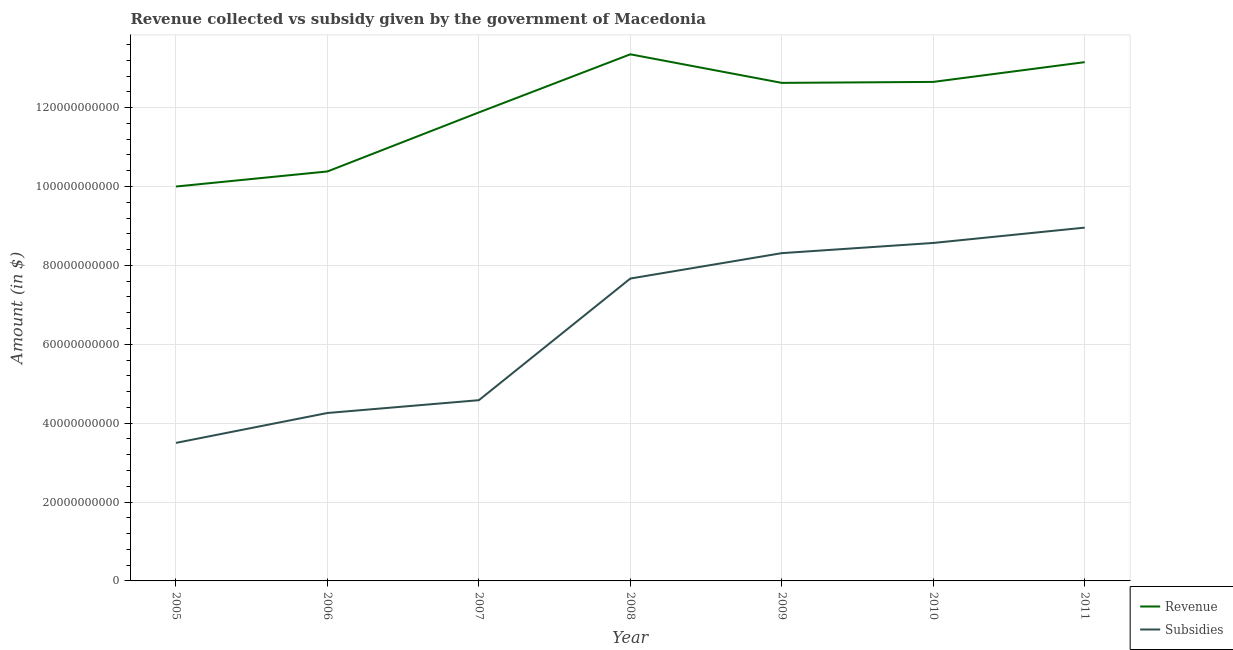How many different coloured lines are there?
Make the answer very short. 2. Is the number of lines equal to the number of legend labels?
Provide a short and direct response. Yes. What is the amount of revenue collected in 2008?
Your answer should be very brief. 1.34e+11. Across all years, what is the maximum amount of revenue collected?
Offer a terse response. 1.34e+11. Across all years, what is the minimum amount of revenue collected?
Your response must be concise. 1.00e+11. What is the total amount of revenue collected in the graph?
Provide a succinct answer. 8.40e+11. What is the difference between the amount of subsidies given in 2005 and that in 2009?
Keep it short and to the point. -4.81e+1. What is the difference between the amount of subsidies given in 2006 and the amount of revenue collected in 2007?
Offer a terse response. -7.62e+1. What is the average amount of subsidies given per year?
Your answer should be compact. 6.55e+1. In the year 2010, what is the difference between the amount of revenue collected and amount of subsidies given?
Your answer should be very brief. 4.08e+1. What is the ratio of the amount of revenue collected in 2006 to that in 2011?
Provide a succinct answer. 0.79. Is the amount of subsidies given in 2007 less than that in 2011?
Make the answer very short. Yes. What is the difference between the highest and the second highest amount of revenue collected?
Provide a succinct answer. 1.99e+09. What is the difference between the highest and the lowest amount of subsidies given?
Provide a succinct answer. 5.46e+1. Does the amount of subsidies given monotonically increase over the years?
Ensure brevity in your answer.  Yes. Are the values on the major ticks of Y-axis written in scientific E-notation?
Your answer should be compact. No. Where does the legend appear in the graph?
Provide a succinct answer. Bottom right. How are the legend labels stacked?
Provide a short and direct response. Vertical. What is the title of the graph?
Provide a succinct answer. Revenue collected vs subsidy given by the government of Macedonia. Does "Under five" appear as one of the legend labels in the graph?
Provide a short and direct response. No. What is the label or title of the X-axis?
Offer a very short reply. Year. What is the label or title of the Y-axis?
Offer a very short reply. Amount (in $). What is the Amount (in $) in Revenue in 2005?
Provide a short and direct response. 1.00e+11. What is the Amount (in $) in Subsidies in 2005?
Offer a terse response. 3.50e+1. What is the Amount (in $) of Revenue in 2006?
Give a very brief answer. 1.04e+11. What is the Amount (in $) in Subsidies in 2006?
Provide a short and direct response. 4.26e+1. What is the Amount (in $) of Revenue in 2007?
Your answer should be very brief. 1.19e+11. What is the Amount (in $) in Subsidies in 2007?
Your response must be concise. 4.58e+1. What is the Amount (in $) of Revenue in 2008?
Offer a very short reply. 1.34e+11. What is the Amount (in $) in Subsidies in 2008?
Provide a short and direct response. 7.67e+1. What is the Amount (in $) of Revenue in 2009?
Your answer should be very brief. 1.26e+11. What is the Amount (in $) in Subsidies in 2009?
Offer a terse response. 8.31e+1. What is the Amount (in $) in Revenue in 2010?
Your answer should be compact. 1.27e+11. What is the Amount (in $) in Subsidies in 2010?
Make the answer very short. 8.57e+1. What is the Amount (in $) of Revenue in 2011?
Offer a terse response. 1.32e+11. What is the Amount (in $) in Subsidies in 2011?
Provide a short and direct response. 8.96e+1. Across all years, what is the maximum Amount (in $) of Revenue?
Your response must be concise. 1.34e+11. Across all years, what is the maximum Amount (in $) of Subsidies?
Make the answer very short. 8.96e+1. Across all years, what is the minimum Amount (in $) of Revenue?
Provide a succinct answer. 1.00e+11. Across all years, what is the minimum Amount (in $) of Subsidies?
Offer a very short reply. 3.50e+1. What is the total Amount (in $) of Revenue in the graph?
Your response must be concise. 8.40e+11. What is the total Amount (in $) in Subsidies in the graph?
Provide a succinct answer. 4.58e+11. What is the difference between the Amount (in $) of Revenue in 2005 and that in 2006?
Offer a very short reply. -3.82e+09. What is the difference between the Amount (in $) of Subsidies in 2005 and that in 2006?
Make the answer very short. -7.58e+09. What is the difference between the Amount (in $) in Revenue in 2005 and that in 2007?
Offer a terse response. -1.88e+1. What is the difference between the Amount (in $) of Subsidies in 2005 and that in 2007?
Your response must be concise. -1.08e+1. What is the difference between the Amount (in $) of Revenue in 2005 and that in 2008?
Make the answer very short. -3.35e+1. What is the difference between the Amount (in $) of Subsidies in 2005 and that in 2008?
Your response must be concise. -4.17e+1. What is the difference between the Amount (in $) in Revenue in 2005 and that in 2009?
Offer a terse response. -2.63e+1. What is the difference between the Amount (in $) in Subsidies in 2005 and that in 2009?
Ensure brevity in your answer.  -4.81e+1. What is the difference between the Amount (in $) in Revenue in 2005 and that in 2010?
Provide a succinct answer. -2.65e+1. What is the difference between the Amount (in $) of Subsidies in 2005 and that in 2010?
Make the answer very short. -5.07e+1. What is the difference between the Amount (in $) in Revenue in 2005 and that in 2011?
Give a very brief answer. -3.15e+1. What is the difference between the Amount (in $) of Subsidies in 2005 and that in 2011?
Make the answer very short. -5.46e+1. What is the difference between the Amount (in $) in Revenue in 2006 and that in 2007?
Provide a short and direct response. -1.50e+1. What is the difference between the Amount (in $) of Subsidies in 2006 and that in 2007?
Ensure brevity in your answer.  -3.25e+09. What is the difference between the Amount (in $) in Revenue in 2006 and that in 2008?
Provide a succinct answer. -2.97e+1. What is the difference between the Amount (in $) of Subsidies in 2006 and that in 2008?
Your answer should be very brief. -3.41e+1. What is the difference between the Amount (in $) of Revenue in 2006 and that in 2009?
Your answer should be compact. -2.25e+1. What is the difference between the Amount (in $) in Subsidies in 2006 and that in 2009?
Give a very brief answer. -4.05e+1. What is the difference between the Amount (in $) of Revenue in 2006 and that in 2010?
Make the answer very short. -2.27e+1. What is the difference between the Amount (in $) of Subsidies in 2006 and that in 2010?
Offer a terse response. -4.31e+1. What is the difference between the Amount (in $) in Revenue in 2006 and that in 2011?
Your answer should be very brief. -2.77e+1. What is the difference between the Amount (in $) in Subsidies in 2006 and that in 2011?
Give a very brief answer. -4.70e+1. What is the difference between the Amount (in $) in Revenue in 2007 and that in 2008?
Ensure brevity in your answer.  -1.47e+1. What is the difference between the Amount (in $) in Subsidies in 2007 and that in 2008?
Make the answer very short. -3.08e+1. What is the difference between the Amount (in $) of Revenue in 2007 and that in 2009?
Keep it short and to the point. -7.49e+09. What is the difference between the Amount (in $) of Subsidies in 2007 and that in 2009?
Your answer should be compact. -3.73e+1. What is the difference between the Amount (in $) of Revenue in 2007 and that in 2010?
Your answer should be compact. -7.73e+09. What is the difference between the Amount (in $) in Subsidies in 2007 and that in 2010?
Your answer should be very brief. -3.99e+1. What is the difference between the Amount (in $) in Revenue in 2007 and that in 2011?
Provide a succinct answer. -1.27e+1. What is the difference between the Amount (in $) of Subsidies in 2007 and that in 2011?
Give a very brief answer. -4.37e+1. What is the difference between the Amount (in $) of Revenue in 2008 and that in 2009?
Provide a succinct answer. 7.24e+09. What is the difference between the Amount (in $) of Subsidies in 2008 and that in 2009?
Keep it short and to the point. -6.44e+09. What is the difference between the Amount (in $) of Revenue in 2008 and that in 2010?
Your response must be concise. 7.00e+09. What is the difference between the Amount (in $) of Subsidies in 2008 and that in 2010?
Offer a very short reply. -9.02e+09. What is the difference between the Amount (in $) of Revenue in 2008 and that in 2011?
Offer a very short reply. 1.99e+09. What is the difference between the Amount (in $) in Subsidies in 2008 and that in 2011?
Give a very brief answer. -1.29e+1. What is the difference between the Amount (in $) of Revenue in 2009 and that in 2010?
Ensure brevity in your answer.  -2.45e+08. What is the difference between the Amount (in $) of Subsidies in 2009 and that in 2010?
Your answer should be compact. -2.58e+09. What is the difference between the Amount (in $) of Revenue in 2009 and that in 2011?
Keep it short and to the point. -5.25e+09. What is the difference between the Amount (in $) of Subsidies in 2009 and that in 2011?
Your answer should be very brief. -6.47e+09. What is the difference between the Amount (in $) of Revenue in 2010 and that in 2011?
Keep it short and to the point. -5.01e+09. What is the difference between the Amount (in $) in Subsidies in 2010 and that in 2011?
Ensure brevity in your answer.  -3.89e+09. What is the difference between the Amount (in $) in Revenue in 2005 and the Amount (in $) in Subsidies in 2006?
Your answer should be compact. 5.74e+1. What is the difference between the Amount (in $) in Revenue in 2005 and the Amount (in $) in Subsidies in 2007?
Offer a very short reply. 5.42e+1. What is the difference between the Amount (in $) of Revenue in 2005 and the Amount (in $) of Subsidies in 2008?
Your answer should be very brief. 2.33e+1. What is the difference between the Amount (in $) of Revenue in 2005 and the Amount (in $) of Subsidies in 2009?
Provide a succinct answer. 1.69e+1. What is the difference between the Amount (in $) of Revenue in 2005 and the Amount (in $) of Subsidies in 2010?
Your answer should be compact. 1.43e+1. What is the difference between the Amount (in $) in Revenue in 2005 and the Amount (in $) in Subsidies in 2011?
Ensure brevity in your answer.  1.04e+1. What is the difference between the Amount (in $) in Revenue in 2006 and the Amount (in $) in Subsidies in 2007?
Ensure brevity in your answer.  5.80e+1. What is the difference between the Amount (in $) in Revenue in 2006 and the Amount (in $) in Subsidies in 2008?
Ensure brevity in your answer.  2.71e+1. What is the difference between the Amount (in $) in Revenue in 2006 and the Amount (in $) in Subsidies in 2009?
Ensure brevity in your answer.  2.07e+1. What is the difference between the Amount (in $) in Revenue in 2006 and the Amount (in $) in Subsidies in 2010?
Your answer should be compact. 1.81e+1. What is the difference between the Amount (in $) in Revenue in 2006 and the Amount (in $) in Subsidies in 2011?
Provide a short and direct response. 1.42e+1. What is the difference between the Amount (in $) in Revenue in 2007 and the Amount (in $) in Subsidies in 2008?
Provide a short and direct response. 4.21e+1. What is the difference between the Amount (in $) in Revenue in 2007 and the Amount (in $) in Subsidies in 2009?
Make the answer very short. 3.57e+1. What is the difference between the Amount (in $) of Revenue in 2007 and the Amount (in $) of Subsidies in 2010?
Provide a short and direct response. 3.31e+1. What is the difference between the Amount (in $) in Revenue in 2007 and the Amount (in $) in Subsidies in 2011?
Provide a succinct answer. 2.92e+1. What is the difference between the Amount (in $) in Revenue in 2008 and the Amount (in $) in Subsidies in 2009?
Give a very brief answer. 5.04e+1. What is the difference between the Amount (in $) in Revenue in 2008 and the Amount (in $) in Subsidies in 2010?
Provide a succinct answer. 4.78e+1. What is the difference between the Amount (in $) of Revenue in 2008 and the Amount (in $) of Subsidies in 2011?
Your answer should be compact. 4.39e+1. What is the difference between the Amount (in $) of Revenue in 2009 and the Amount (in $) of Subsidies in 2010?
Your answer should be compact. 4.06e+1. What is the difference between the Amount (in $) of Revenue in 2009 and the Amount (in $) of Subsidies in 2011?
Provide a succinct answer. 3.67e+1. What is the difference between the Amount (in $) in Revenue in 2010 and the Amount (in $) in Subsidies in 2011?
Your response must be concise. 3.69e+1. What is the average Amount (in $) in Revenue per year?
Offer a terse response. 1.20e+11. What is the average Amount (in $) of Subsidies per year?
Give a very brief answer. 6.55e+1. In the year 2005, what is the difference between the Amount (in $) in Revenue and Amount (in $) in Subsidies?
Provide a succinct answer. 6.50e+1. In the year 2006, what is the difference between the Amount (in $) in Revenue and Amount (in $) in Subsidies?
Give a very brief answer. 6.12e+1. In the year 2007, what is the difference between the Amount (in $) in Revenue and Amount (in $) in Subsidies?
Give a very brief answer. 7.30e+1. In the year 2008, what is the difference between the Amount (in $) of Revenue and Amount (in $) of Subsidies?
Keep it short and to the point. 5.68e+1. In the year 2009, what is the difference between the Amount (in $) of Revenue and Amount (in $) of Subsidies?
Give a very brief answer. 4.32e+1. In the year 2010, what is the difference between the Amount (in $) in Revenue and Amount (in $) in Subsidies?
Give a very brief answer. 4.08e+1. In the year 2011, what is the difference between the Amount (in $) of Revenue and Amount (in $) of Subsidies?
Provide a succinct answer. 4.19e+1. What is the ratio of the Amount (in $) of Revenue in 2005 to that in 2006?
Offer a terse response. 0.96. What is the ratio of the Amount (in $) of Subsidies in 2005 to that in 2006?
Make the answer very short. 0.82. What is the ratio of the Amount (in $) of Revenue in 2005 to that in 2007?
Provide a succinct answer. 0.84. What is the ratio of the Amount (in $) in Subsidies in 2005 to that in 2007?
Keep it short and to the point. 0.76. What is the ratio of the Amount (in $) of Revenue in 2005 to that in 2008?
Keep it short and to the point. 0.75. What is the ratio of the Amount (in $) in Subsidies in 2005 to that in 2008?
Your answer should be compact. 0.46. What is the ratio of the Amount (in $) of Revenue in 2005 to that in 2009?
Ensure brevity in your answer.  0.79. What is the ratio of the Amount (in $) in Subsidies in 2005 to that in 2009?
Your response must be concise. 0.42. What is the ratio of the Amount (in $) in Revenue in 2005 to that in 2010?
Ensure brevity in your answer.  0.79. What is the ratio of the Amount (in $) of Subsidies in 2005 to that in 2010?
Provide a short and direct response. 0.41. What is the ratio of the Amount (in $) in Revenue in 2005 to that in 2011?
Your answer should be compact. 0.76. What is the ratio of the Amount (in $) in Subsidies in 2005 to that in 2011?
Keep it short and to the point. 0.39. What is the ratio of the Amount (in $) of Revenue in 2006 to that in 2007?
Your answer should be compact. 0.87. What is the ratio of the Amount (in $) in Subsidies in 2006 to that in 2007?
Keep it short and to the point. 0.93. What is the ratio of the Amount (in $) in Revenue in 2006 to that in 2008?
Keep it short and to the point. 0.78. What is the ratio of the Amount (in $) of Subsidies in 2006 to that in 2008?
Your answer should be compact. 0.56. What is the ratio of the Amount (in $) of Revenue in 2006 to that in 2009?
Your answer should be compact. 0.82. What is the ratio of the Amount (in $) of Subsidies in 2006 to that in 2009?
Your response must be concise. 0.51. What is the ratio of the Amount (in $) of Revenue in 2006 to that in 2010?
Make the answer very short. 0.82. What is the ratio of the Amount (in $) of Subsidies in 2006 to that in 2010?
Give a very brief answer. 0.5. What is the ratio of the Amount (in $) in Revenue in 2006 to that in 2011?
Offer a very short reply. 0.79. What is the ratio of the Amount (in $) in Subsidies in 2006 to that in 2011?
Your response must be concise. 0.48. What is the ratio of the Amount (in $) in Revenue in 2007 to that in 2008?
Your response must be concise. 0.89. What is the ratio of the Amount (in $) of Subsidies in 2007 to that in 2008?
Make the answer very short. 0.6. What is the ratio of the Amount (in $) of Revenue in 2007 to that in 2009?
Offer a very short reply. 0.94. What is the ratio of the Amount (in $) in Subsidies in 2007 to that in 2009?
Your response must be concise. 0.55. What is the ratio of the Amount (in $) in Revenue in 2007 to that in 2010?
Offer a terse response. 0.94. What is the ratio of the Amount (in $) in Subsidies in 2007 to that in 2010?
Your response must be concise. 0.53. What is the ratio of the Amount (in $) in Revenue in 2007 to that in 2011?
Give a very brief answer. 0.9. What is the ratio of the Amount (in $) of Subsidies in 2007 to that in 2011?
Offer a very short reply. 0.51. What is the ratio of the Amount (in $) in Revenue in 2008 to that in 2009?
Your response must be concise. 1.06. What is the ratio of the Amount (in $) of Subsidies in 2008 to that in 2009?
Your answer should be very brief. 0.92. What is the ratio of the Amount (in $) in Revenue in 2008 to that in 2010?
Ensure brevity in your answer.  1.06. What is the ratio of the Amount (in $) of Subsidies in 2008 to that in 2010?
Offer a terse response. 0.89. What is the ratio of the Amount (in $) in Revenue in 2008 to that in 2011?
Offer a terse response. 1.02. What is the ratio of the Amount (in $) of Subsidies in 2008 to that in 2011?
Keep it short and to the point. 0.86. What is the ratio of the Amount (in $) of Revenue in 2009 to that in 2010?
Keep it short and to the point. 1. What is the ratio of the Amount (in $) of Subsidies in 2009 to that in 2010?
Offer a very short reply. 0.97. What is the ratio of the Amount (in $) of Revenue in 2009 to that in 2011?
Ensure brevity in your answer.  0.96. What is the ratio of the Amount (in $) in Subsidies in 2009 to that in 2011?
Keep it short and to the point. 0.93. What is the ratio of the Amount (in $) in Revenue in 2010 to that in 2011?
Offer a very short reply. 0.96. What is the ratio of the Amount (in $) in Subsidies in 2010 to that in 2011?
Offer a very short reply. 0.96. What is the difference between the highest and the second highest Amount (in $) in Revenue?
Ensure brevity in your answer.  1.99e+09. What is the difference between the highest and the second highest Amount (in $) of Subsidies?
Your answer should be very brief. 3.89e+09. What is the difference between the highest and the lowest Amount (in $) in Revenue?
Ensure brevity in your answer.  3.35e+1. What is the difference between the highest and the lowest Amount (in $) in Subsidies?
Make the answer very short. 5.46e+1. 